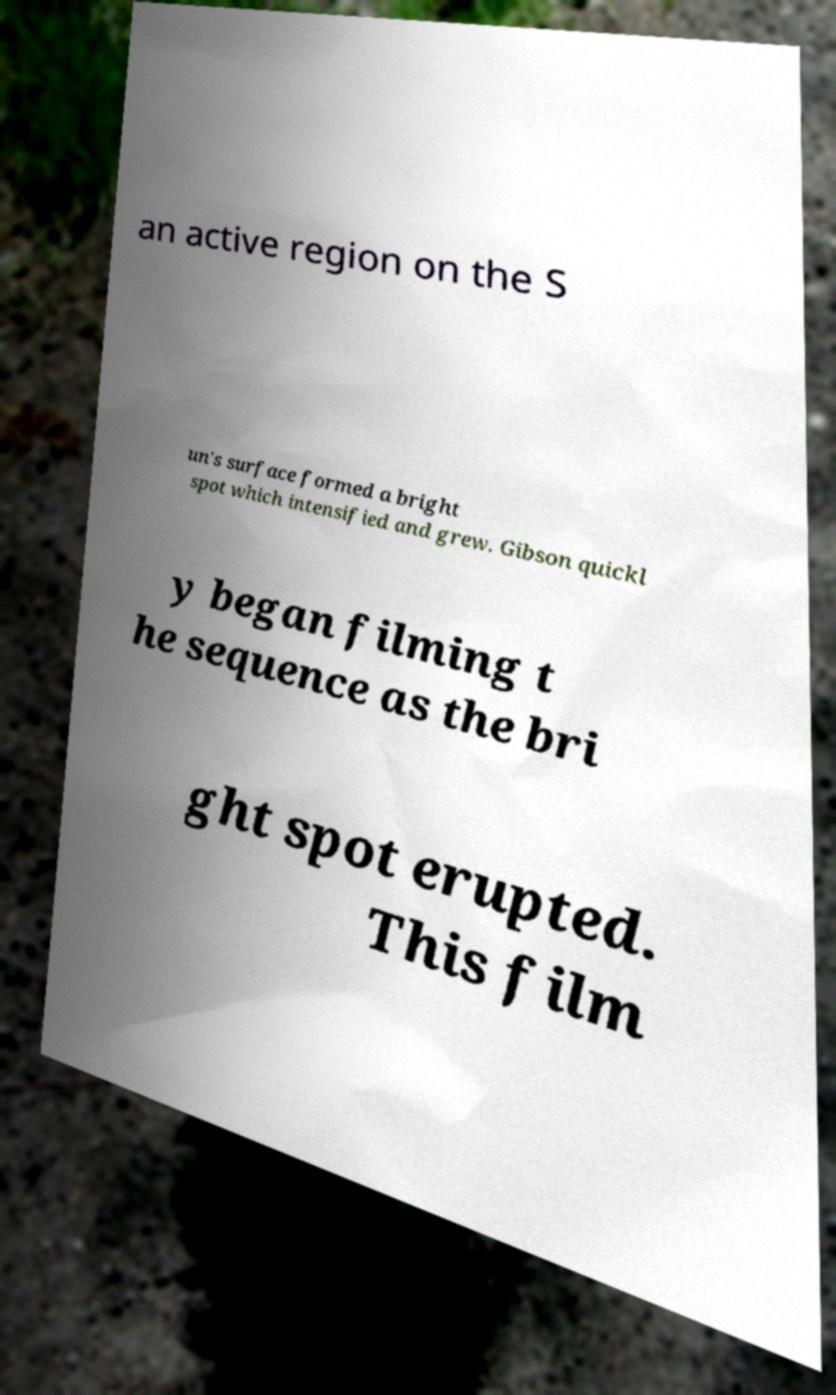Can you accurately transcribe the text from the provided image for me? an active region on the S un's surface formed a bright spot which intensified and grew. Gibson quickl y began filming t he sequence as the bri ght spot erupted. This film 